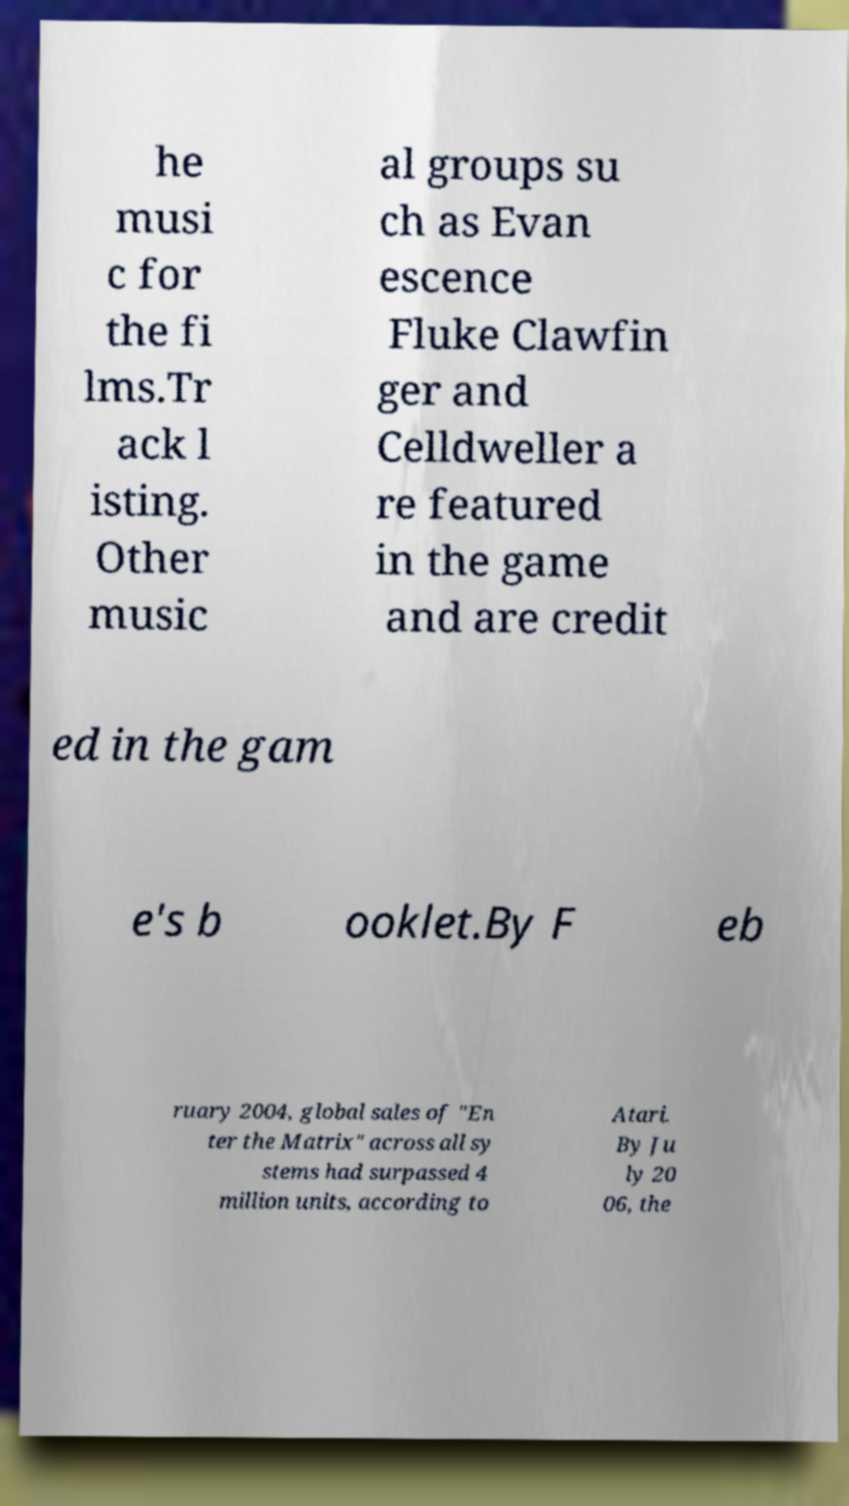Can you accurately transcribe the text from the provided image for me? he musi c for the fi lms.Tr ack l isting. Other music al groups su ch as Evan escence Fluke Clawfin ger and Celldweller a re featured in the game and are credit ed in the gam e's b ooklet.By F eb ruary 2004, global sales of "En ter the Matrix" across all sy stems had surpassed 4 million units, according to Atari. By Ju ly 20 06, the 